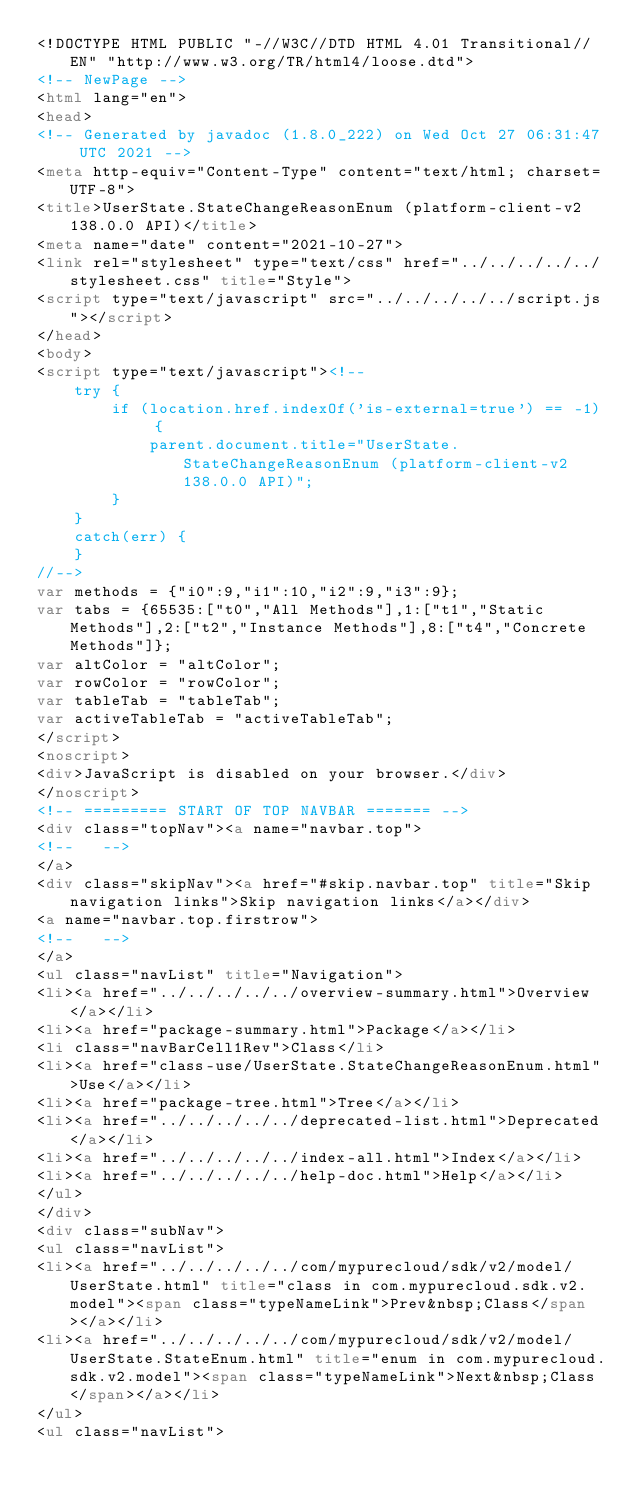<code> <loc_0><loc_0><loc_500><loc_500><_HTML_><!DOCTYPE HTML PUBLIC "-//W3C//DTD HTML 4.01 Transitional//EN" "http://www.w3.org/TR/html4/loose.dtd">
<!-- NewPage -->
<html lang="en">
<head>
<!-- Generated by javadoc (1.8.0_222) on Wed Oct 27 06:31:47 UTC 2021 -->
<meta http-equiv="Content-Type" content="text/html; charset=UTF-8">
<title>UserState.StateChangeReasonEnum (platform-client-v2 138.0.0 API)</title>
<meta name="date" content="2021-10-27">
<link rel="stylesheet" type="text/css" href="../../../../../stylesheet.css" title="Style">
<script type="text/javascript" src="../../../../../script.js"></script>
</head>
<body>
<script type="text/javascript"><!--
    try {
        if (location.href.indexOf('is-external=true') == -1) {
            parent.document.title="UserState.StateChangeReasonEnum (platform-client-v2 138.0.0 API)";
        }
    }
    catch(err) {
    }
//-->
var methods = {"i0":9,"i1":10,"i2":9,"i3":9};
var tabs = {65535:["t0","All Methods"],1:["t1","Static Methods"],2:["t2","Instance Methods"],8:["t4","Concrete Methods"]};
var altColor = "altColor";
var rowColor = "rowColor";
var tableTab = "tableTab";
var activeTableTab = "activeTableTab";
</script>
<noscript>
<div>JavaScript is disabled on your browser.</div>
</noscript>
<!-- ========= START OF TOP NAVBAR ======= -->
<div class="topNav"><a name="navbar.top">
<!--   -->
</a>
<div class="skipNav"><a href="#skip.navbar.top" title="Skip navigation links">Skip navigation links</a></div>
<a name="navbar.top.firstrow">
<!--   -->
</a>
<ul class="navList" title="Navigation">
<li><a href="../../../../../overview-summary.html">Overview</a></li>
<li><a href="package-summary.html">Package</a></li>
<li class="navBarCell1Rev">Class</li>
<li><a href="class-use/UserState.StateChangeReasonEnum.html">Use</a></li>
<li><a href="package-tree.html">Tree</a></li>
<li><a href="../../../../../deprecated-list.html">Deprecated</a></li>
<li><a href="../../../../../index-all.html">Index</a></li>
<li><a href="../../../../../help-doc.html">Help</a></li>
</ul>
</div>
<div class="subNav">
<ul class="navList">
<li><a href="../../../../../com/mypurecloud/sdk/v2/model/UserState.html" title="class in com.mypurecloud.sdk.v2.model"><span class="typeNameLink">Prev&nbsp;Class</span></a></li>
<li><a href="../../../../../com/mypurecloud/sdk/v2/model/UserState.StateEnum.html" title="enum in com.mypurecloud.sdk.v2.model"><span class="typeNameLink">Next&nbsp;Class</span></a></li>
</ul>
<ul class="navList"></code> 